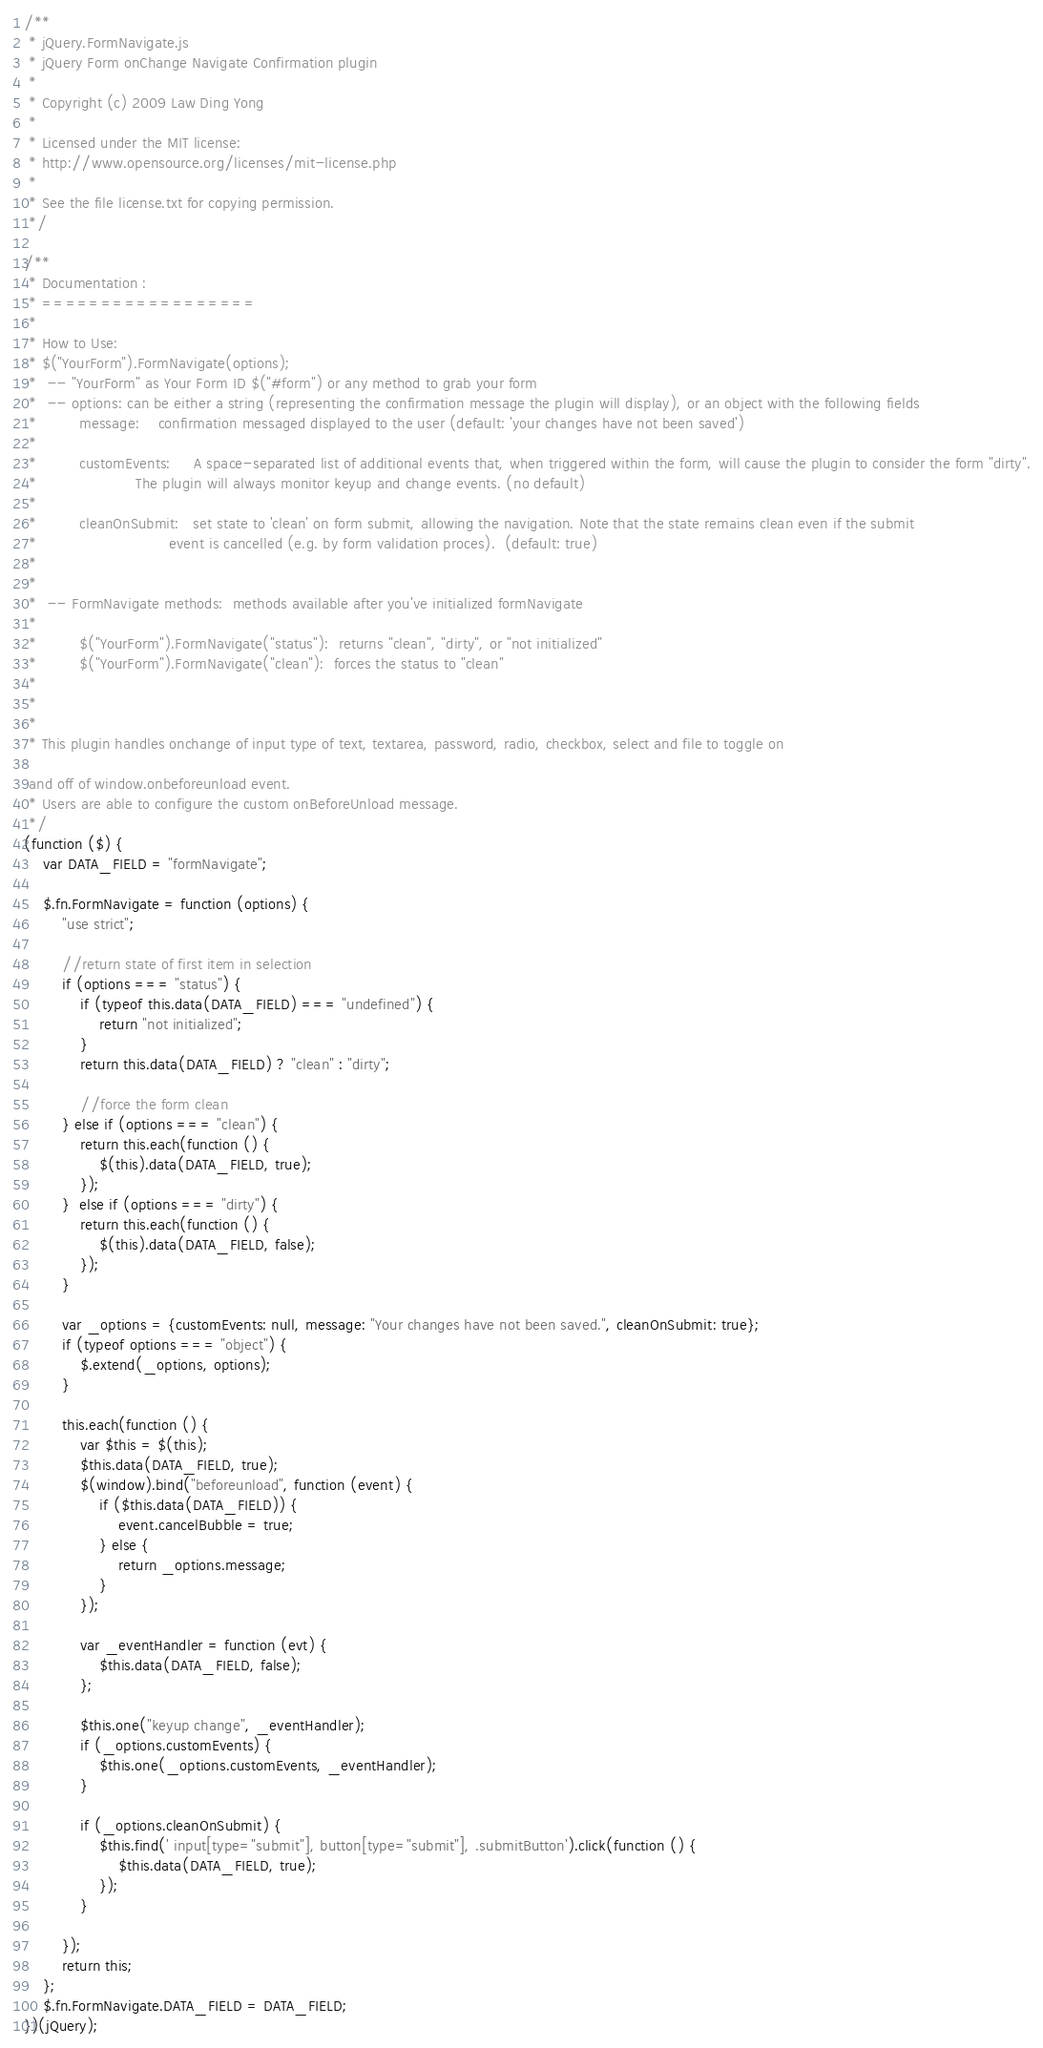<code> <loc_0><loc_0><loc_500><loc_500><_JavaScript_>/**
 * jQuery.FormNavigate.js
 * jQuery Form onChange Navigate Confirmation plugin
 *
 * Copyright (c) 2009 Law Ding Yong
 *
 * Licensed under the MIT license:
 * http://www.opensource.org/licenses/mit-license.php
 *
 * See the file license.txt for copying permission.
 */

/**
 * Documentation :
 * ==================
 *
 * How to Use:
 * $("YourForm").FormNavigate(options);
 *  -- "YourForm" as Your Form ID $("#form") or any method to grab your form
 *  -- options: can be either a string (representing the confirmation message the plugin will display), or an object with the following fields
 *         message:    confirmation messaged displayed to the user (default: 'your changes have not been saved')
 *
 *         customEvents:     A space-separated list of additional events that, when triggered within the form, will cause the plugin to consider the form "dirty".
 *                     The plugin will always monitor keyup and change events. (no default)
 *
 *         cleanOnSubmit:   set state to 'clean' on form submit, allowing the navigation. Note that the state remains clean even if the submit
 *                            event is cancelled (e.g. by form validation proces).  (default: true)
 *
 *
 *  -- FormNavigate methods:  methods available after you've initialized formNavigate
 *
 *         $("YourForm").FormNavigate("status"):  returns "clean", "dirty", or "not initialized"
 *         $("YourForm").FormNavigate("clean"):  forces the status to "clean"
 *
 *
 *
 * This plugin handles onchange of input type of text, textarea, password, radio, checkbox, select and file to toggle on

 and off of window.onbeforeunload event.
 * Users are able to configure the custom onBeforeUnload message.
 */
(function ($) {
    var DATA_FIELD = "formNavigate";

    $.fn.FormNavigate = function (options) {
        "use strict";

        //return state of first item in selection
        if (options === "status") {
            if (typeof this.data(DATA_FIELD) === "undefined") {
                return "not initialized";
            }
            return this.data(DATA_FIELD) ? "clean" : "dirty";

            //force the form clean
        } else if (options === "clean") {
            return this.each(function () {
                $(this).data(DATA_FIELD, true);
            });
        }  else if (options === "dirty") {
            return this.each(function () {
                $(this).data(DATA_FIELD, false);
            });
        }

        var _options = {customEvents: null, message: "Your changes have not been saved.", cleanOnSubmit: true};
        if (typeof options === "object") {
            $.extend(_options, options);
        }

        this.each(function () {
            var $this = $(this);
            $this.data(DATA_FIELD, true);
            $(window).bind("beforeunload", function (event) {
                if ($this.data(DATA_FIELD)) {
                    event.cancelBubble = true;
                } else {
                    return _options.message;
                }
            });

            var _eventHandler = function (evt) {
                $this.data(DATA_FIELD, false);
            };

            $this.one("keyup change", _eventHandler);
            if (_options.customEvents) {
                $this.one(_options.customEvents, _eventHandler);
            }

            if (_options.cleanOnSubmit) {
                $this.find(' input[type="submit"], button[type="submit"], .submitButton').click(function () {
                    $this.data(DATA_FIELD, true);
                });
            }

        });
        return this;
    };
    $.fn.FormNavigate.DATA_FIELD = DATA_FIELD;
})(jQuery);
</code> 